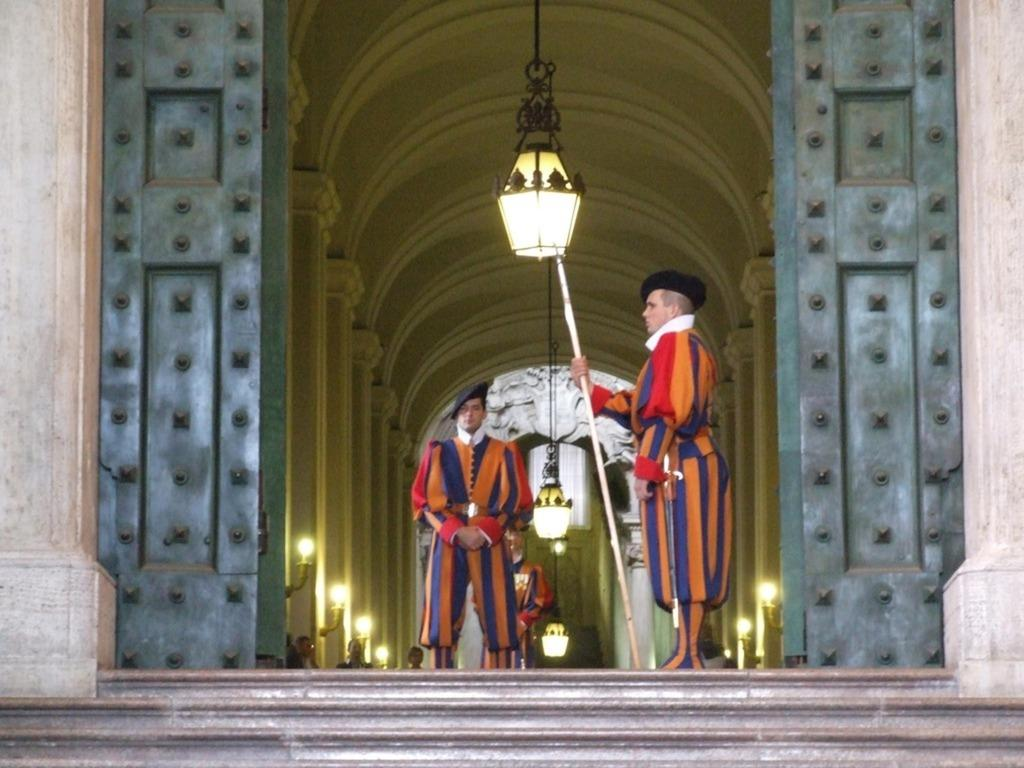What are the two people in the foreground of the image doing? The two people in the foreground of the image are wearing costumes. Can you describe the lighting in the image? There is a light in the image. What architectural feature can be seen in the image? There is a door and pillars in the image. What is located at the bottom of the image? There is a staircase at the bottom of the image. How does the street affect the temperature in the image? There is no street present in the image, so it cannot affect the temperature. 